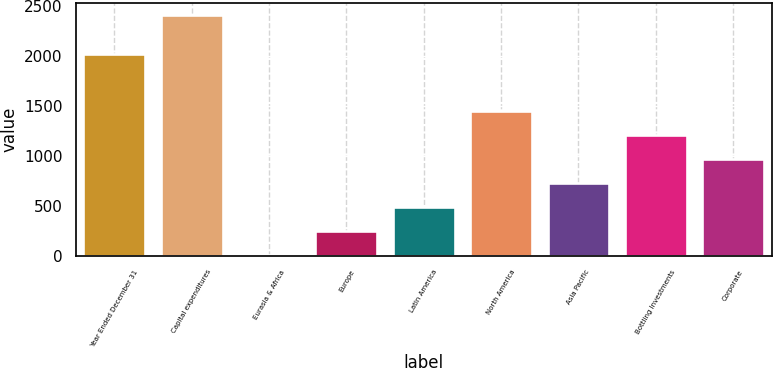Convert chart. <chart><loc_0><loc_0><loc_500><loc_500><bar_chart><fcel>Year Ended December 31<fcel>Capital expenditures<fcel>Eurasia & Africa<fcel>Europe<fcel>Latin America<fcel>North America<fcel>Asia Pacific<fcel>Bottling Investments<fcel>Corporate<nl><fcel>2014<fcel>2406<fcel>1.3<fcel>241.77<fcel>482.24<fcel>1444.12<fcel>722.71<fcel>1203.65<fcel>963.18<nl></chart> 